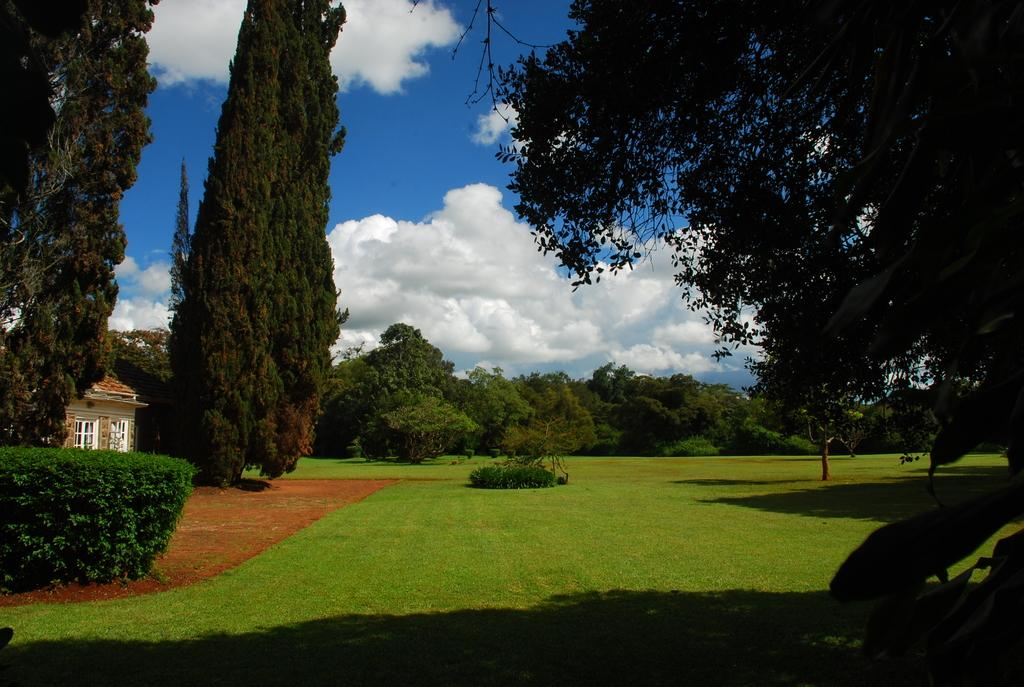What type of ground is visible in the image? There is a greenery ground in the image. Where is the house located in the image? The house is in the left corner of the image. What can be seen in the background of the image? There are trees in the background of the image. What type of sand can be seen in the image? There is no sand present in the image; it features a greenery ground. What scientific theory is being discussed in the image? There is no discussion of any scientific theory in the image. 